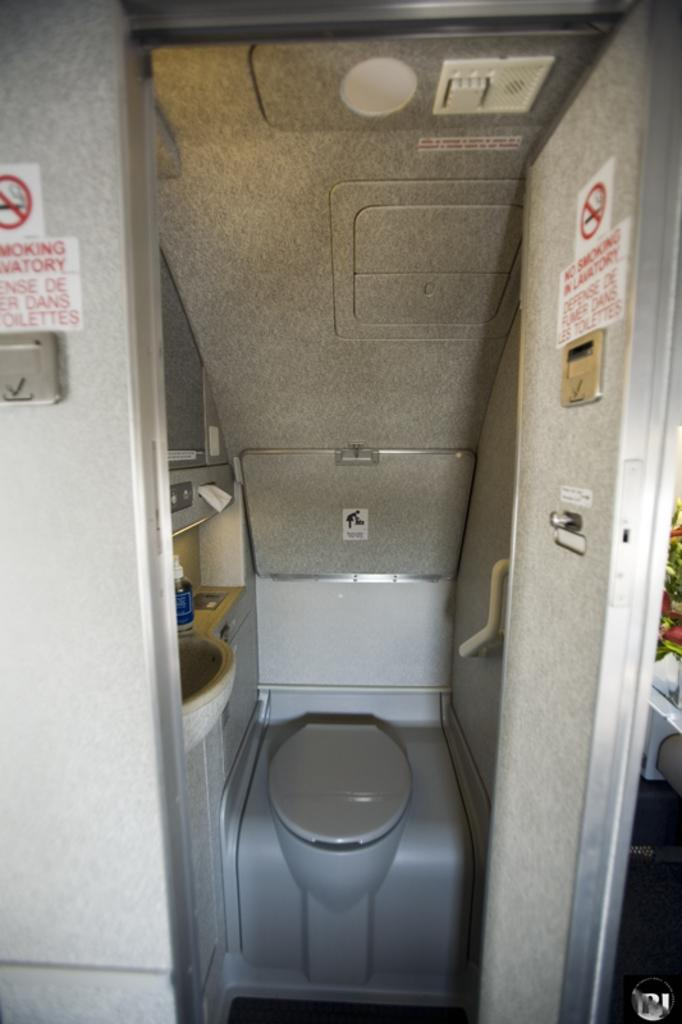<image>
Describe the image concisely. An airplane bathroom has a No Smoking sign on the door. 